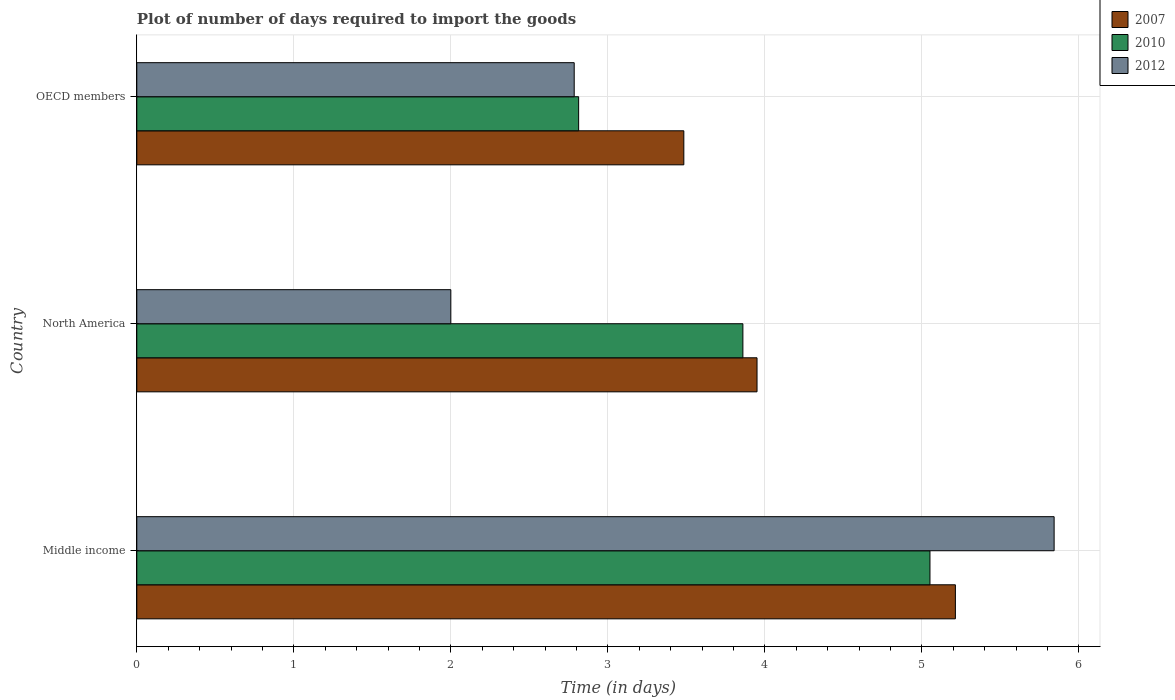Are the number of bars per tick equal to the number of legend labels?
Offer a very short reply. Yes. How many bars are there on the 2nd tick from the bottom?
Offer a very short reply. 3. What is the time required to import goods in 2012 in OECD members?
Offer a terse response. 2.79. Across all countries, what is the maximum time required to import goods in 2007?
Provide a succinct answer. 5.21. Across all countries, what is the minimum time required to import goods in 2010?
Give a very brief answer. 2.81. What is the total time required to import goods in 2010 in the graph?
Offer a very short reply. 11.73. What is the difference between the time required to import goods in 2012 in Middle income and that in North America?
Offer a very short reply. 3.84. What is the difference between the time required to import goods in 2007 in North America and the time required to import goods in 2012 in OECD members?
Ensure brevity in your answer.  1.16. What is the average time required to import goods in 2007 per country?
Ensure brevity in your answer.  4.22. What is the difference between the time required to import goods in 2007 and time required to import goods in 2012 in OECD members?
Provide a short and direct response. 0.7. What is the ratio of the time required to import goods in 2012 in Middle income to that in OECD members?
Provide a succinct answer. 2.1. Is the time required to import goods in 2012 in Middle income less than that in North America?
Give a very brief answer. No. What is the difference between the highest and the second highest time required to import goods in 2007?
Your answer should be very brief. 1.26. What is the difference between the highest and the lowest time required to import goods in 2012?
Make the answer very short. 3.84. In how many countries, is the time required to import goods in 2012 greater than the average time required to import goods in 2012 taken over all countries?
Give a very brief answer. 1. Is the sum of the time required to import goods in 2010 in Middle income and North America greater than the maximum time required to import goods in 2012 across all countries?
Offer a terse response. Yes. What does the 1st bar from the bottom in North America represents?
Provide a short and direct response. 2007. Are all the bars in the graph horizontal?
Ensure brevity in your answer.  Yes. What is the difference between two consecutive major ticks on the X-axis?
Give a very brief answer. 1. Are the values on the major ticks of X-axis written in scientific E-notation?
Provide a succinct answer. No. Does the graph contain any zero values?
Provide a succinct answer. No. Does the graph contain grids?
Offer a very short reply. Yes. How many legend labels are there?
Your answer should be very brief. 3. What is the title of the graph?
Ensure brevity in your answer.  Plot of number of days required to import the goods. What is the label or title of the X-axis?
Give a very brief answer. Time (in days). What is the label or title of the Y-axis?
Offer a very short reply. Country. What is the Time (in days) of 2007 in Middle income?
Keep it short and to the point. 5.21. What is the Time (in days) of 2010 in Middle income?
Ensure brevity in your answer.  5.05. What is the Time (in days) in 2012 in Middle income?
Your answer should be compact. 5.84. What is the Time (in days) in 2007 in North America?
Provide a succinct answer. 3.95. What is the Time (in days) in 2010 in North America?
Offer a very short reply. 3.86. What is the Time (in days) in 2012 in North America?
Keep it short and to the point. 2. What is the Time (in days) of 2007 in OECD members?
Give a very brief answer. 3.48. What is the Time (in days) in 2010 in OECD members?
Offer a very short reply. 2.81. What is the Time (in days) of 2012 in OECD members?
Offer a very short reply. 2.79. Across all countries, what is the maximum Time (in days) in 2007?
Offer a very short reply. 5.21. Across all countries, what is the maximum Time (in days) of 2010?
Your answer should be very brief. 5.05. Across all countries, what is the maximum Time (in days) of 2012?
Offer a very short reply. 5.84. Across all countries, what is the minimum Time (in days) of 2007?
Your response must be concise. 3.48. Across all countries, what is the minimum Time (in days) in 2010?
Your answer should be very brief. 2.81. Across all countries, what is the minimum Time (in days) in 2012?
Your answer should be compact. 2. What is the total Time (in days) of 2007 in the graph?
Ensure brevity in your answer.  12.65. What is the total Time (in days) in 2010 in the graph?
Offer a very short reply. 11.73. What is the total Time (in days) of 2012 in the graph?
Your answer should be compact. 10.63. What is the difference between the Time (in days) in 2007 in Middle income and that in North America?
Your response must be concise. 1.26. What is the difference between the Time (in days) in 2010 in Middle income and that in North America?
Keep it short and to the point. 1.19. What is the difference between the Time (in days) in 2012 in Middle income and that in North America?
Offer a very short reply. 3.84. What is the difference between the Time (in days) in 2007 in Middle income and that in OECD members?
Keep it short and to the point. 1.73. What is the difference between the Time (in days) of 2010 in Middle income and that in OECD members?
Offer a terse response. 2.24. What is the difference between the Time (in days) in 2012 in Middle income and that in OECD members?
Make the answer very short. 3.06. What is the difference between the Time (in days) in 2007 in North America and that in OECD members?
Your answer should be very brief. 0.47. What is the difference between the Time (in days) of 2010 in North America and that in OECD members?
Provide a short and direct response. 1.05. What is the difference between the Time (in days) in 2012 in North America and that in OECD members?
Provide a succinct answer. -0.79. What is the difference between the Time (in days) of 2007 in Middle income and the Time (in days) of 2010 in North America?
Ensure brevity in your answer.  1.35. What is the difference between the Time (in days) of 2007 in Middle income and the Time (in days) of 2012 in North America?
Ensure brevity in your answer.  3.21. What is the difference between the Time (in days) in 2010 in Middle income and the Time (in days) in 2012 in North America?
Your answer should be compact. 3.05. What is the difference between the Time (in days) in 2007 in Middle income and the Time (in days) in 2010 in OECD members?
Offer a terse response. 2.4. What is the difference between the Time (in days) in 2007 in Middle income and the Time (in days) in 2012 in OECD members?
Provide a short and direct response. 2.43. What is the difference between the Time (in days) of 2010 in Middle income and the Time (in days) of 2012 in OECD members?
Make the answer very short. 2.27. What is the difference between the Time (in days) of 2007 in North America and the Time (in days) of 2010 in OECD members?
Give a very brief answer. 1.14. What is the difference between the Time (in days) of 2007 in North America and the Time (in days) of 2012 in OECD members?
Offer a very short reply. 1.16. What is the difference between the Time (in days) in 2010 in North America and the Time (in days) in 2012 in OECD members?
Keep it short and to the point. 1.07. What is the average Time (in days) of 2007 per country?
Offer a terse response. 4.22. What is the average Time (in days) in 2010 per country?
Give a very brief answer. 3.91. What is the average Time (in days) of 2012 per country?
Your answer should be very brief. 3.54. What is the difference between the Time (in days) of 2007 and Time (in days) of 2010 in Middle income?
Ensure brevity in your answer.  0.16. What is the difference between the Time (in days) in 2007 and Time (in days) in 2012 in Middle income?
Provide a short and direct response. -0.63. What is the difference between the Time (in days) of 2010 and Time (in days) of 2012 in Middle income?
Keep it short and to the point. -0.79. What is the difference between the Time (in days) in 2007 and Time (in days) in 2010 in North America?
Your response must be concise. 0.09. What is the difference between the Time (in days) of 2007 and Time (in days) of 2012 in North America?
Provide a short and direct response. 1.95. What is the difference between the Time (in days) in 2010 and Time (in days) in 2012 in North America?
Offer a very short reply. 1.86. What is the difference between the Time (in days) of 2007 and Time (in days) of 2010 in OECD members?
Your answer should be compact. 0.67. What is the difference between the Time (in days) of 2007 and Time (in days) of 2012 in OECD members?
Your response must be concise. 0.7. What is the difference between the Time (in days) of 2010 and Time (in days) of 2012 in OECD members?
Your response must be concise. 0.03. What is the ratio of the Time (in days) in 2007 in Middle income to that in North America?
Your answer should be compact. 1.32. What is the ratio of the Time (in days) of 2010 in Middle income to that in North America?
Offer a very short reply. 1.31. What is the ratio of the Time (in days) in 2012 in Middle income to that in North America?
Provide a succinct answer. 2.92. What is the ratio of the Time (in days) of 2007 in Middle income to that in OECD members?
Your answer should be very brief. 1.5. What is the ratio of the Time (in days) of 2010 in Middle income to that in OECD members?
Give a very brief answer. 1.8. What is the ratio of the Time (in days) in 2012 in Middle income to that in OECD members?
Give a very brief answer. 2.1. What is the ratio of the Time (in days) of 2007 in North America to that in OECD members?
Provide a succinct answer. 1.13. What is the ratio of the Time (in days) of 2010 in North America to that in OECD members?
Your answer should be compact. 1.37. What is the ratio of the Time (in days) of 2012 in North America to that in OECD members?
Ensure brevity in your answer.  0.72. What is the difference between the highest and the second highest Time (in days) of 2007?
Your response must be concise. 1.26. What is the difference between the highest and the second highest Time (in days) in 2010?
Ensure brevity in your answer.  1.19. What is the difference between the highest and the second highest Time (in days) of 2012?
Make the answer very short. 3.06. What is the difference between the highest and the lowest Time (in days) in 2007?
Provide a succinct answer. 1.73. What is the difference between the highest and the lowest Time (in days) in 2010?
Ensure brevity in your answer.  2.24. What is the difference between the highest and the lowest Time (in days) in 2012?
Provide a short and direct response. 3.84. 